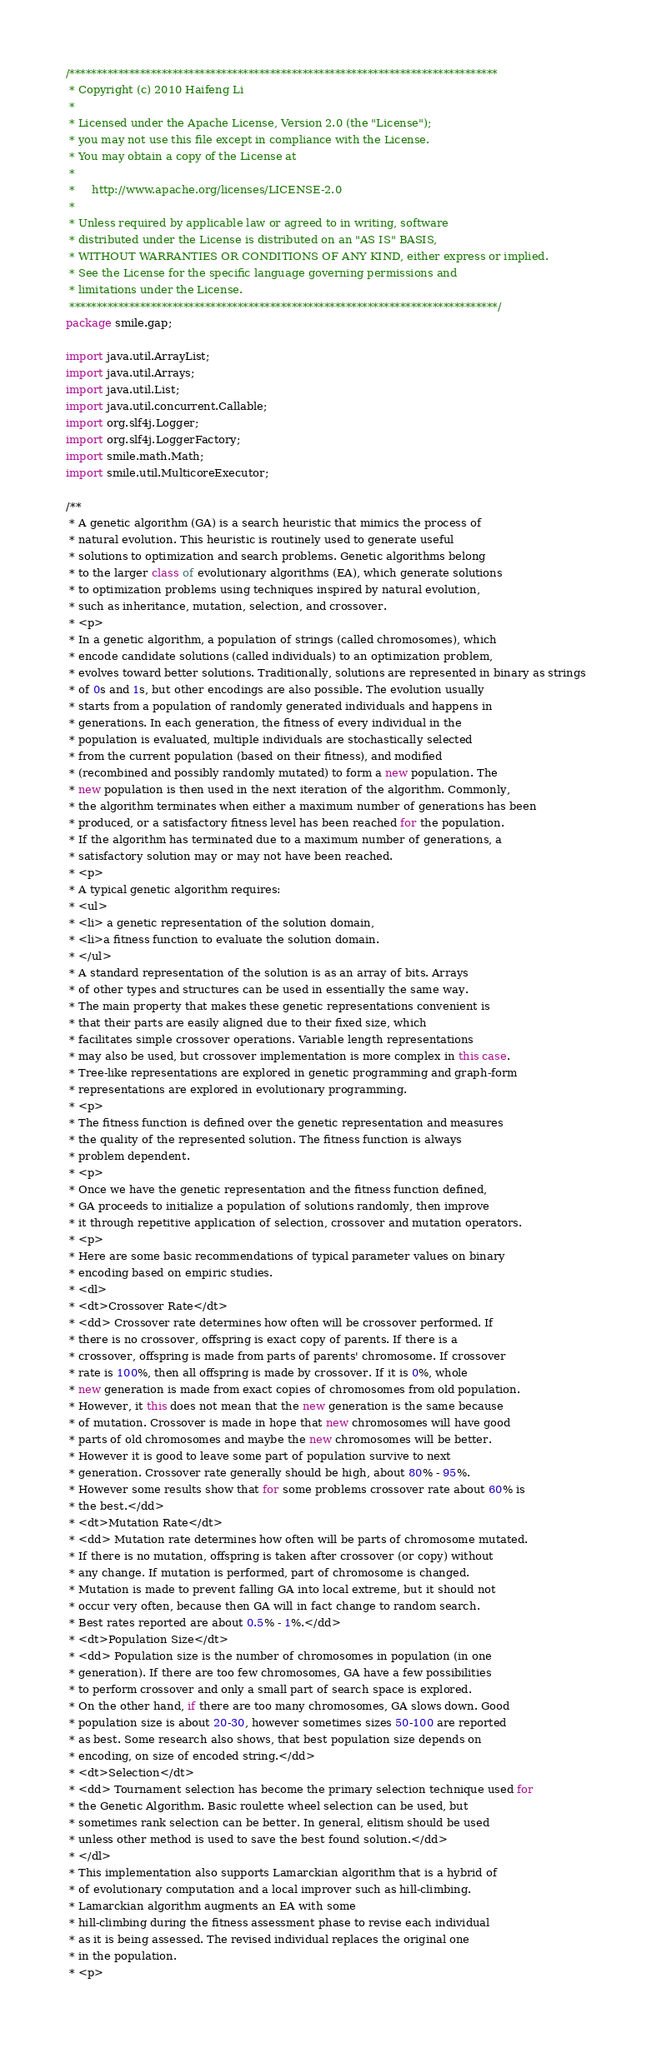<code> <loc_0><loc_0><loc_500><loc_500><_Java_>/*******************************************************************************
 * Copyright (c) 2010 Haifeng Li
 *   
 * Licensed under the Apache License, Version 2.0 (the "License");
 * you may not use this file except in compliance with the License.
 * You may obtain a copy of the License at
 *  
 *     http://www.apache.org/licenses/LICENSE-2.0
 *
 * Unless required by applicable law or agreed to in writing, software
 * distributed under the License is distributed on an "AS IS" BASIS,
 * WITHOUT WARRANTIES OR CONDITIONS OF ANY KIND, either express or implied.
 * See the License for the specific language governing permissions and
 * limitations under the License.
 *******************************************************************************/
package smile.gap;

import java.util.ArrayList;
import java.util.Arrays;
import java.util.List;
import java.util.concurrent.Callable;
import org.slf4j.Logger;
import org.slf4j.LoggerFactory;
import smile.math.Math;
import smile.util.MulticoreExecutor;

/**
 * A genetic algorithm (GA) is a search heuristic that mimics the process of
 * natural evolution. This heuristic is routinely used to generate useful
 * solutions to optimization and search problems. Genetic algorithms belong
 * to the larger class of evolutionary algorithms (EA), which generate solutions
 * to optimization problems using techniques inspired by natural evolution,
 * such as inheritance, mutation, selection, and crossover.
 * <p>
 * In a genetic algorithm, a population of strings (called chromosomes), which
 * encode candidate solutions (called individuals) to an optimization problem,
 * evolves toward better solutions. Traditionally, solutions are represented in binary as strings
 * of 0s and 1s, but other encodings are also possible. The evolution usually
 * starts from a population of randomly generated individuals and happens in
 * generations. In each generation, the fitness of every individual in the
 * population is evaluated, multiple individuals are stochastically selected
 * from the current population (based on their fitness), and modified
 * (recombined and possibly randomly mutated) to form a new population. The
 * new population is then used in the next iteration of the algorithm. Commonly,
 * the algorithm terminates when either a maximum number of generations has been
 * produced, or a satisfactory fitness level has been reached for the population.
 * If the algorithm has terminated due to a maximum number of generations, a
 * satisfactory solution may or may not have been reached.
 * <p>
 * A typical genetic algorithm requires:
 * <ul>
 * <li> a genetic representation of the solution domain,
 * <li>a fitness function to evaluate the solution domain.
 * </ul>
 * A standard representation of the solution is as an array of bits. Arrays
 * of other types and structures can be used in essentially the same way.
 * The main property that makes these genetic representations convenient is
 * that their parts are easily aligned due to their fixed size, which
 * facilitates simple crossover operations. Variable length representations
 * may also be used, but crossover implementation is more complex in this case.
 * Tree-like representations are explored in genetic programming and graph-form
 * representations are explored in evolutionary programming.
 * <p>
 * The fitness function is defined over the genetic representation and measures
 * the quality of the represented solution. The fitness function is always
 * problem dependent.
 * <p>
 * Once we have the genetic representation and the fitness function defined,
 * GA proceeds to initialize a population of solutions randomly, then improve
 * it through repetitive application of selection, crossover and mutation operators.
 * <p>
 * Here are some basic recommendations of typical parameter values on binary
 * encoding based on empiric studies.
 * <dl>
 * <dt>Crossover Rate</dt>
 * <dd> Crossover rate determines how often will be crossover performed. If
 * there is no crossover, offspring is exact copy of parents. If there is a
 * crossover, offspring is made from parts of parents' chromosome. If crossover
 * rate is 100%, then all offspring is made by crossover. If it is 0%, whole
 * new generation is made from exact copies of chromosomes from old population.
 * However, it this does not mean that the new generation is the same because
 * of mutation. Crossover is made in hope that new chromosomes will have good
 * parts of old chromosomes and maybe the new chromosomes will be better.
 * However it is good to leave some part of population survive to next
 * generation. Crossover rate generally should be high, about 80% - 95%.
 * However some results show that for some problems crossover rate about 60% is
 * the best.</dd>
 * <dt>Mutation Rate</dt>
 * <dd> Mutation rate determines how often will be parts of chromosome mutated.
 * If there is no mutation, offspring is taken after crossover (or copy) without
 * any change. If mutation is performed, part of chromosome is changed.
 * Mutation is made to prevent falling GA into local extreme, but it should not
 * occur very often, because then GA will in fact change to random search.
 * Best rates reported are about 0.5% - 1%.</dd>
 * <dt>Population Size</dt>
 * <dd> Population size is the number of chromosomes in population (in one
 * generation). If there are too few chromosomes, GA have a few possibilities
 * to perform crossover and only a small part of search space is explored.
 * On the other hand, if there are too many chromosomes, GA slows down. Good
 * population size is about 20-30, however sometimes sizes 50-100 are reported
 * as best. Some research also shows, that best population size depends on
 * encoding, on size of encoded string.</dd>
 * <dt>Selection</dt>
 * <dd> Tournament selection has become the primary selection technique used for
 * the Genetic Algorithm. Basic roulette wheel selection can be used, but
 * sometimes rank selection can be better. In general, elitism should be used
 * unless other method is used to save the best found solution.</dd>
 * </dl>
 * This implementation also supports Lamarckian algorithm that is a hybrid of
 * of evolutionary computation and a local improver such as hill-climbing.
 * Lamarckian algorithm augments an EA with some
 * hill-climbing during the fitness assessment phase to revise each individual
 * as it is being assessed. The revised individual replaces the original one
 * in the population.
 * <p></code> 